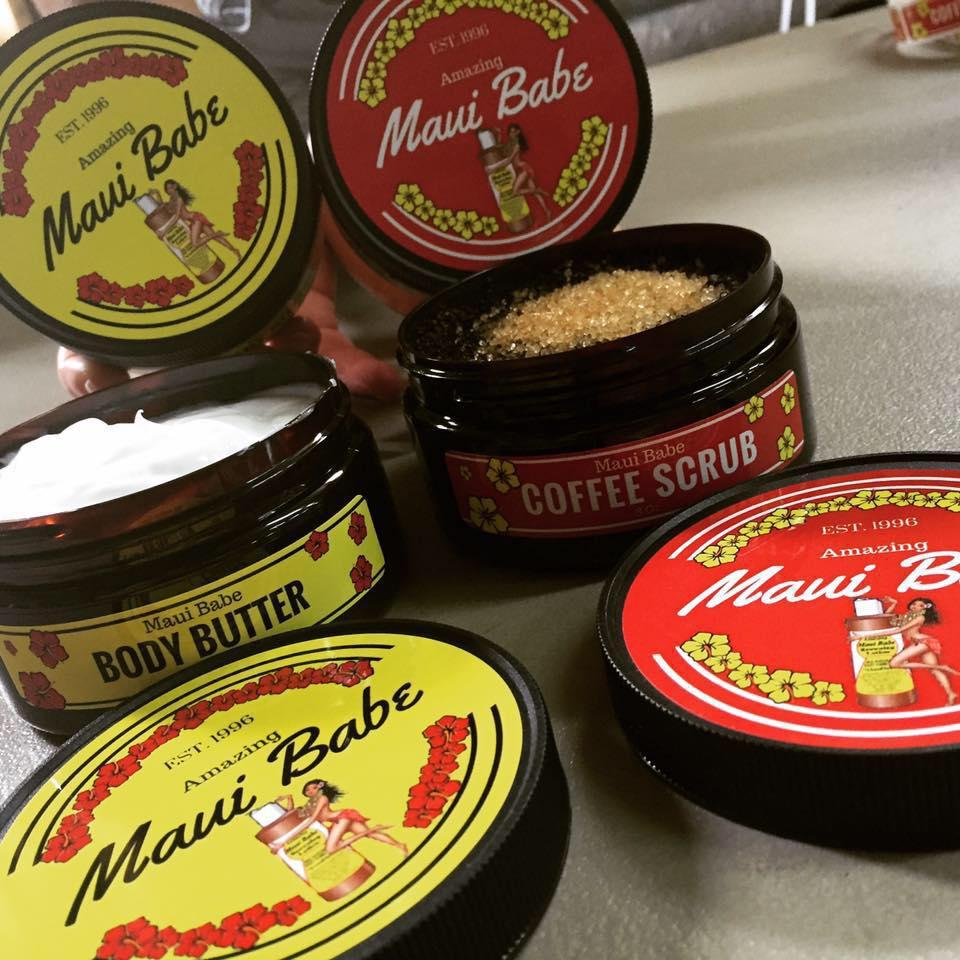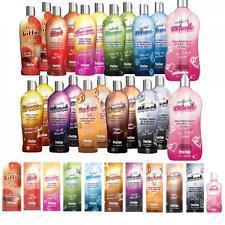The first image is the image on the left, the second image is the image on the right. For the images shown, is this caption "The image to the right features nothing more than one single bottle." true? Answer yes or no. No. The first image is the image on the left, the second image is the image on the right. Evaluate the accuracy of this statement regarding the images: "there is no more then three items". Is it true? Answer yes or no. No. 